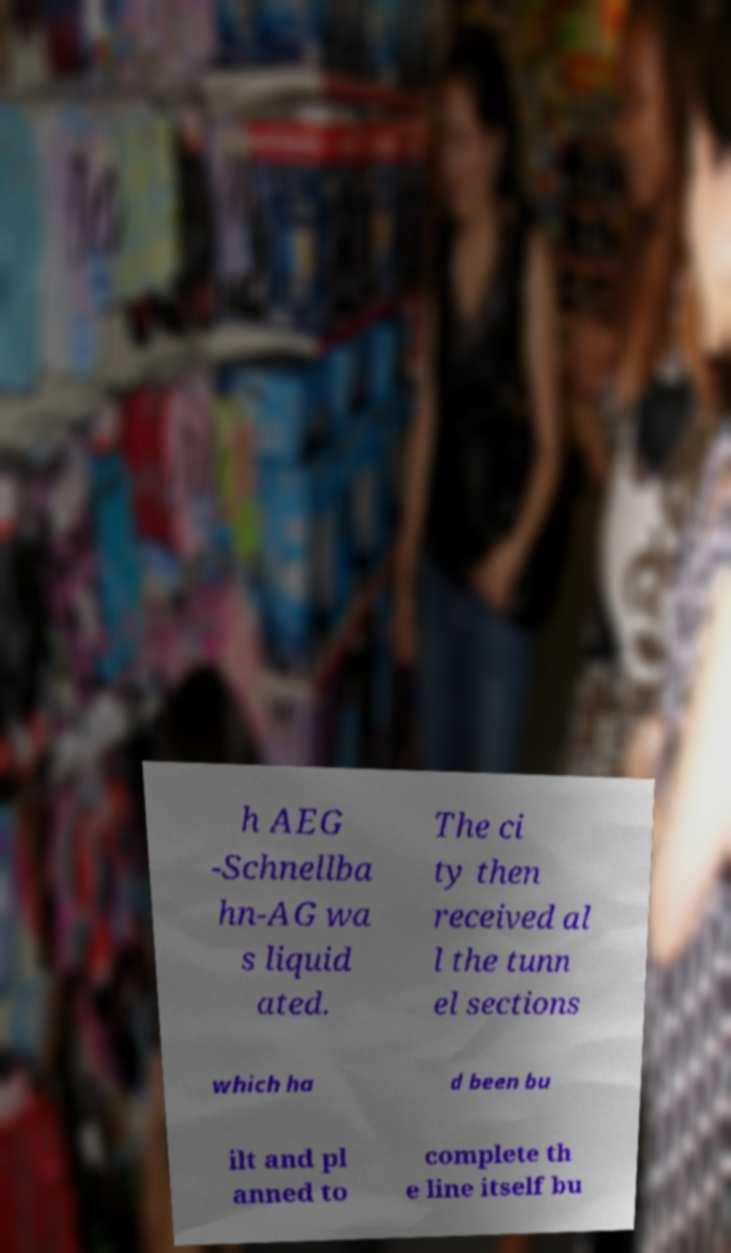There's text embedded in this image that I need extracted. Can you transcribe it verbatim? h AEG -Schnellba hn-AG wa s liquid ated. The ci ty then received al l the tunn el sections which ha d been bu ilt and pl anned to complete th e line itself bu 